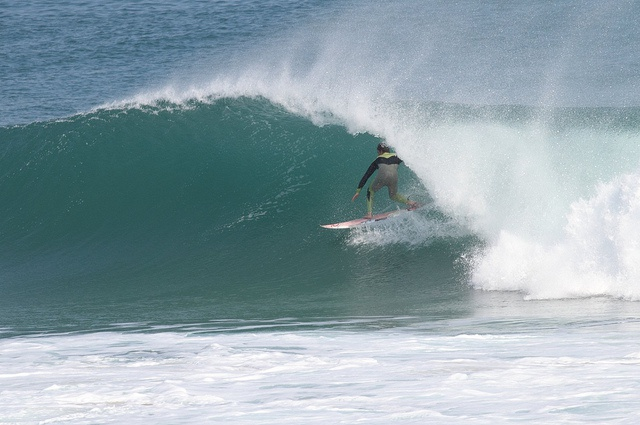Describe the objects in this image and their specific colors. I can see people in gray, black, teal, and darkgray tones and surfboard in gray, darkgray, lightgray, and pink tones in this image. 